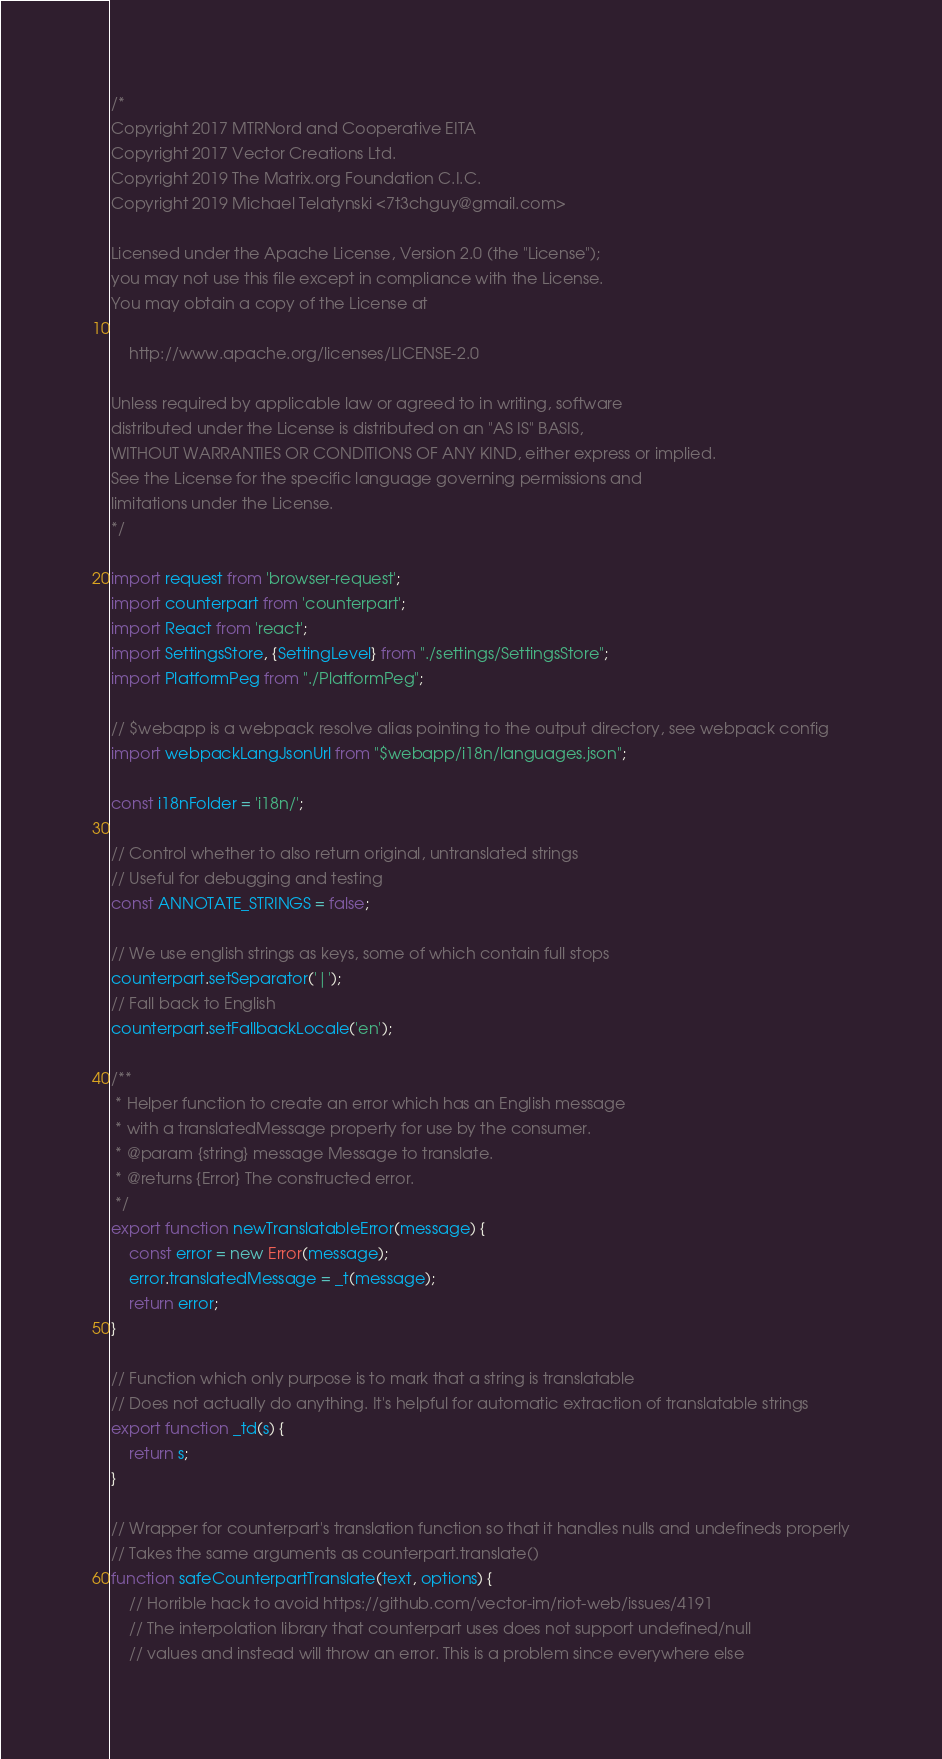<code> <loc_0><loc_0><loc_500><loc_500><_JavaScript_>/*
Copyright 2017 MTRNord and Cooperative EITA
Copyright 2017 Vector Creations Ltd.
Copyright 2019 The Matrix.org Foundation C.I.C.
Copyright 2019 Michael Telatynski <7t3chguy@gmail.com>

Licensed under the Apache License, Version 2.0 (the "License");
you may not use this file except in compliance with the License.
You may obtain a copy of the License at

    http://www.apache.org/licenses/LICENSE-2.0

Unless required by applicable law or agreed to in writing, software
distributed under the License is distributed on an "AS IS" BASIS,
WITHOUT WARRANTIES OR CONDITIONS OF ANY KIND, either express or implied.
See the License for the specific language governing permissions and
limitations under the License.
*/

import request from 'browser-request';
import counterpart from 'counterpart';
import React from 'react';
import SettingsStore, {SettingLevel} from "./settings/SettingsStore";
import PlatformPeg from "./PlatformPeg";

// $webapp is a webpack resolve alias pointing to the output directory, see webpack config
import webpackLangJsonUrl from "$webapp/i18n/languages.json";

const i18nFolder = 'i18n/';

// Control whether to also return original, untranslated strings
// Useful for debugging and testing
const ANNOTATE_STRINGS = false;

// We use english strings as keys, some of which contain full stops
counterpart.setSeparator('|');
// Fall back to English
counterpart.setFallbackLocale('en');

/**
 * Helper function to create an error which has an English message
 * with a translatedMessage property for use by the consumer.
 * @param {string} message Message to translate.
 * @returns {Error} The constructed error.
 */
export function newTranslatableError(message) {
    const error = new Error(message);
    error.translatedMessage = _t(message);
    return error;
}

// Function which only purpose is to mark that a string is translatable
// Does not actually do anything. It's helpful for automatic extraction of translatable strings
export function _td(s) {
    return s;
}

// Wrapper for counterpart's translation function so that it handles nulls and undefineds properly
// Takes the same arguments as counterpart.translate()
function safeCounterpartTranslate(text, options) {
    // Horrible hack to avoid https://github.com/vector-im/riot-web/issues/4191
    // The interpolation library that counterpart uses does not support undefined/null
    // values and instead will throw an error. This is a problem since everywhere else</code> 